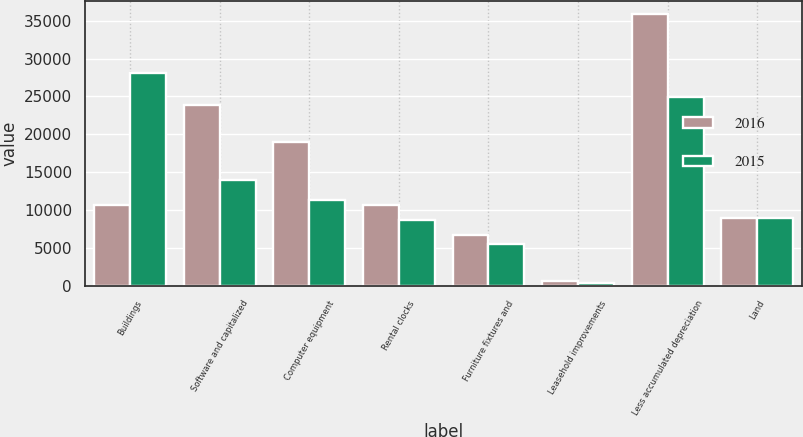Convert chart. <chart><loc_0><loc_0><loc_500><loc_500><stacked_bar_chart><ecel><fcel>Buildings<fcel>Software and capitalized<fcel>Computer equipment<fcel>Rental clocks<fcel>Furniture fixtures and<fcel>Leasehold improvements<fcel>Less accumulated depreciation<fcel>Land<nl><fcel>2016<fcel>10669<fcel>23879<fcel>18987<fcel>10669<fcel>6695<fcel>680<fcel>35833<fcel>8993<nl><fcel>2015<fcel>28154<fcel>13959<fcel>11346<fcel>8750<fcel>5464<fcel>358<fcel>24894<fcel>8993<nl></chart> 